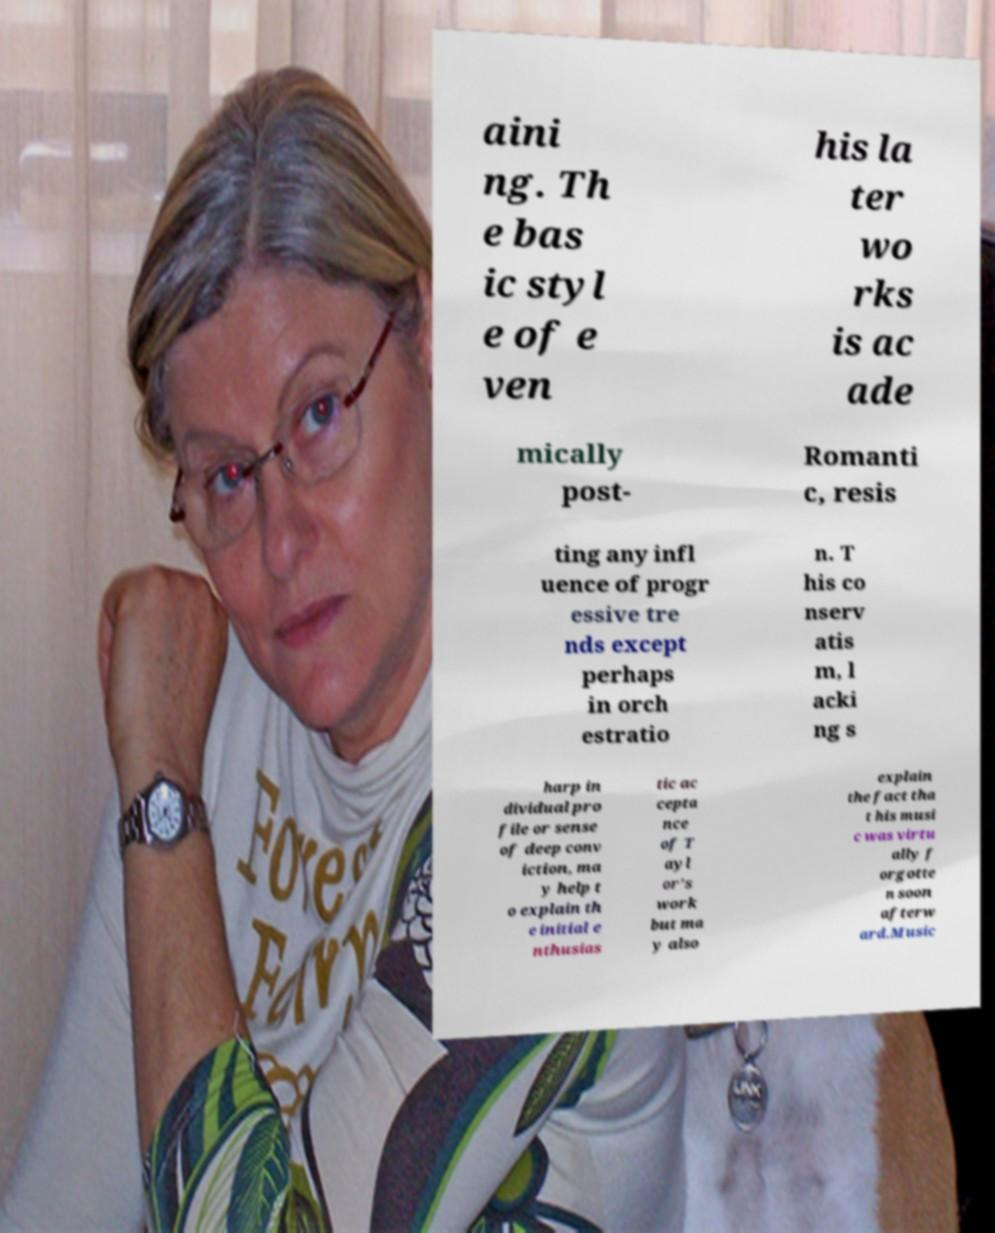There's text embedded in this image that I need extracted. Can you transcribe it verbatim? aini ng. Th e bas ic styl e of e ven his la ter wo rks is ac ade mically post- Romanti c, resis ting any infl uence of progr essive tre nds except perhaps in orch estratio n. T his co nserv atis m, l acki ng s harp in dividual pro file or sense of deep conv iction, ma y help t o explain th e initial e nthusias tic ac cepta nce of T ayl or’s work but ma y also explain the fact tha t his musi c was virtu ally f orgotte n soon afterw ard.Music 